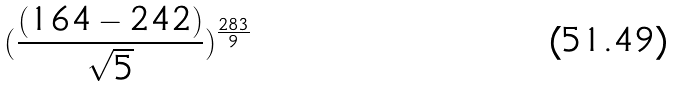<formula> <loc_0><loc_0><loc_500><loc_500>( \frac { ( 1 6 4 - 2 4 2 ) } { \sqrt { 5 } } ) ^ { \frac { 2 8 3 } { 9 } }</formula> 